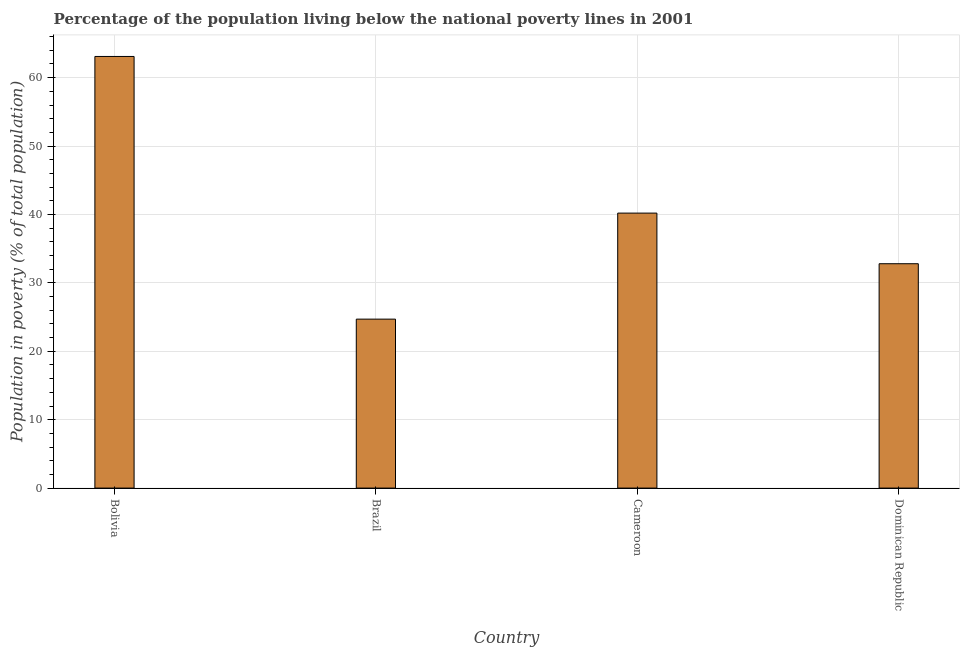Does the graph contain any zero values?
Provide a succinct answer. No. What is the title of the graph?
Make the answer very short. Percentage of the population living below the national poverty lines in 2001. What is the label or title of the X-axis?
Provide a short and direct response. Country. What is the label or title of the Y-axis?
Ensure brevity in your answer.  Population in poverty (% of total population). What is the percentage of population living below poverty line in Dominican Republic?
Provide a succinct answer. 32.8. Across all countries, what is the maximum percentage of population living below poverty line?
Make the answer very short. 63.1. Across all countries, what is the minimum percentage of population living below poverty line?
Offer a terse response. 24.7. In which country was the percentage of population living below poverty line minimum?
Your response must be concise. Brazil. What is the sum of the percentage of population living below poverty line?
Offer a very short reply. 160.8. What is the difference between the percentage of population living below poverty line in Brazil and Dominican Republic?
Offer a very short reply. -8.1. What is the average percentage of population living below poverty line per country?
Your answer should be compact. 40.2. What is the median percentage of population living below poverty line?
Keep it short and to the point. 36.5. What is the ratio of the percentage of population living below poverty line in Bolivia to that in Cameroon?
Provide a short and direct response. 1.57. Is the percentage of population living below poverty line in Brazil less than that in Dominican Republic?
Offer a terse response. Yes. What is the difference between the highest and the second highest percentage of population living below poverty line?
Your answer should be compact. 22.9. Is the sum of the percentage of population living below poverty line in Brazil and Dominican Republic greater than the maximum percentage of population living below poverty line across all countries?
Make the answer very short. No. What is the difference between the highest and the lowest percentage of population living below poverty line?
Offer a terse response. 38.4. How many bars are there?
Make the answer very short. 4. Are all the bars in the graph horizontal?
Offer a very short reply. No. How many countries are there in the graph?
Provide a short and direct response. 4. What is the difference between two consecutive major ticks on the Y-axis?
Your answer should be compact. 10. What is the Population in poverty (% of total population) of Bolivia?
Make the answer very short. 63.1. What is the Population in poverty (% of total population) of Brazil?
Provide a short and direct response. 24.7. What is the Population in poverty (% of total population) in Cameroon?
Your response must be concise. 40.2. What is the Population in poverty (% of total population) of Dominican Republic?
Keep it short and to the point. 32.8. What is the difference between the Population in poverty (% of total population) in Bolivia and Brazil?
Offer a very short reply. 38.4. What is the difference between the Population in poverty (% of total population) in Bolivia and Cameroon?
Your answer should be very brief. 22.9. What is the difference between the Population in poverty (% of total population) in Bolivia and Dominican Republic?
Give a very brief answer. 30.3. What is the difference between the Population in poverty (% of total population) in Brazil and Cameroon?
Provide a succinct answer. -15.5. What is the difference between the Population in poverty (% of total population) in Brazil and Dominican Republic?
Your answer should be very brief. -8.1. What is the difference between the Population in poverty (% of total population) in Cameroon and Dominican Republic?
Keep it short and to the point. 7.4. What is the ratio of the Population in poverty (% of total population) in Bolivia to that in Brazil?
Provide a short and direct response. 2.56. What is the ratio of the Population in poverty (% of total population) in Bolivia to that in Cameroon?
Your response must be concise. 1.57. What is the ratio of the Population in poverty (% of total population) in Bolivia to that in Dominican Republic?
Your answer should be very brief. 1.92. What is the ratio of the Population in poverty (% of total population) in Brazil to that in Cameroon?
Keep it short and to the point. 0.61. What is the ratio of the Population in poverty (% of total population) in Brazil to that in Dominican Republic?
Offer a very short reply. 0.75. What is the ratio of the Population in poverty (% of total population) in Cameroon to that in Dominican Republic?
Your answer should be very brief. 1.23. 